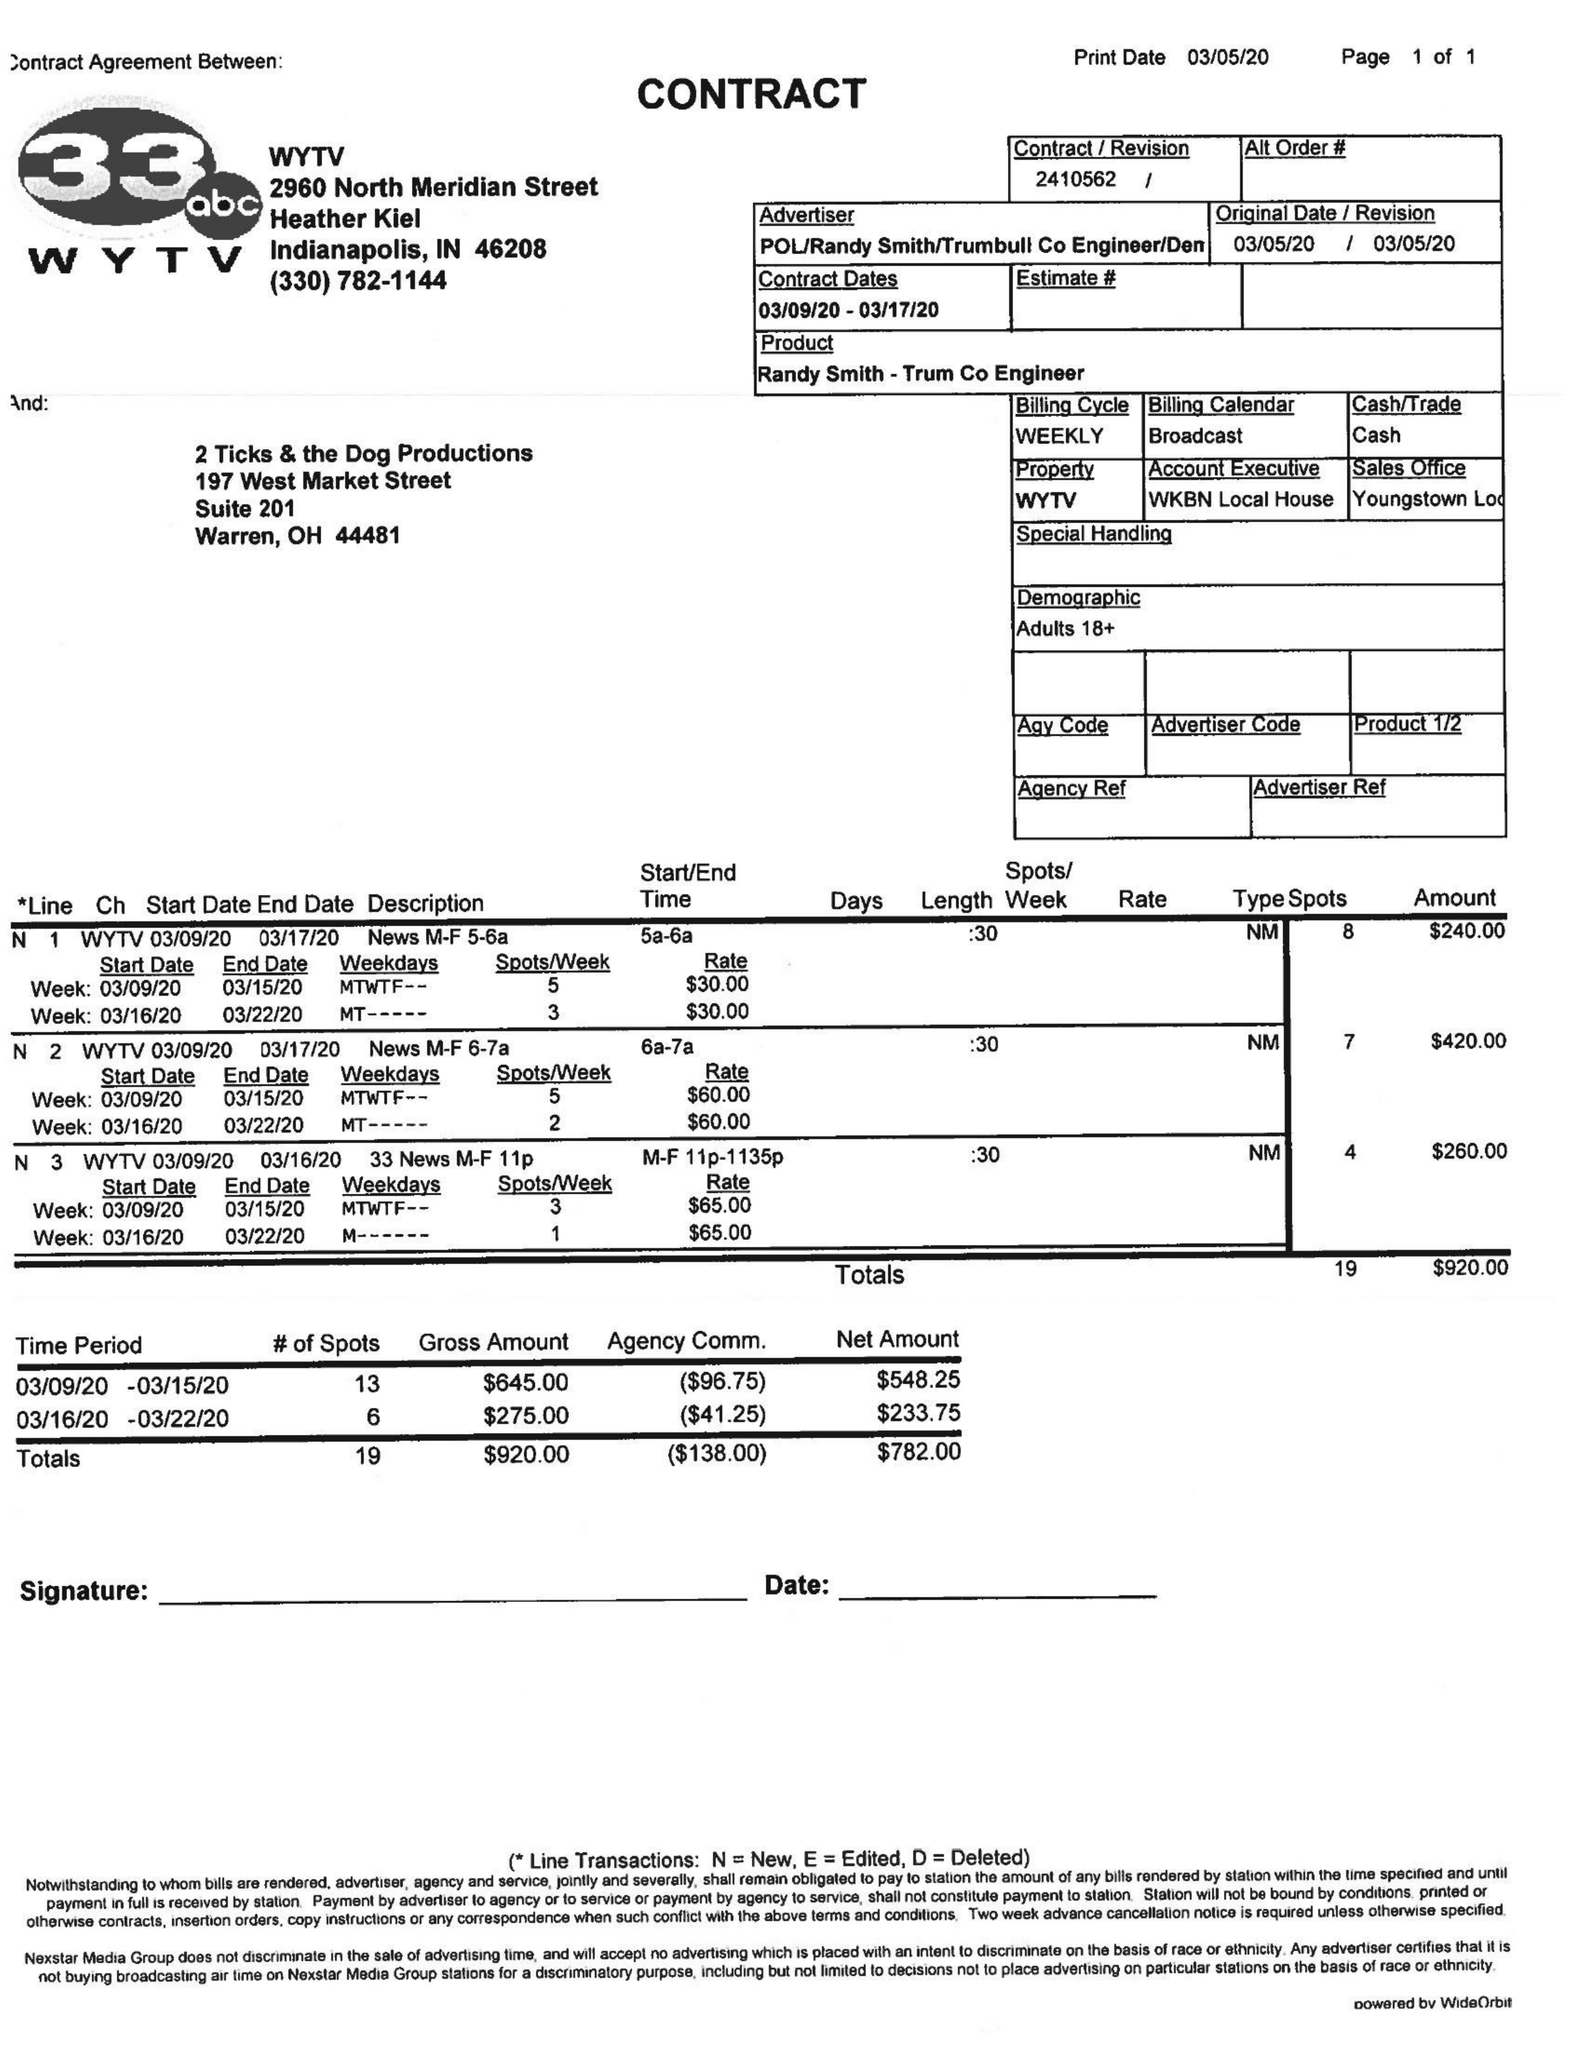What is the value for the flight_from?
Answer the question using a single word or phrase. 03/09/20 